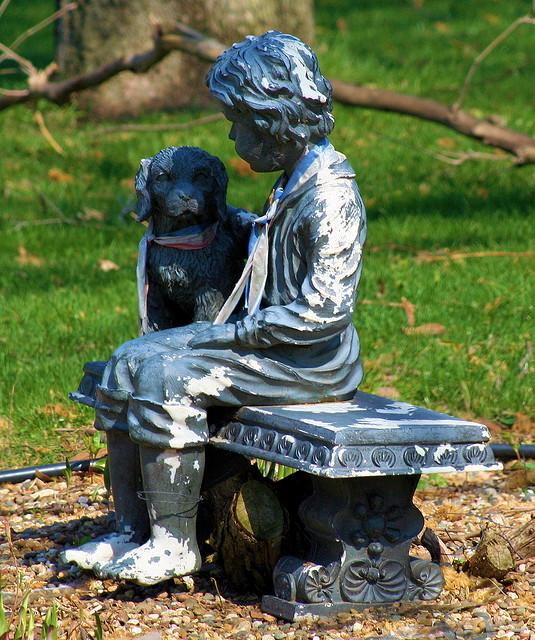Why is this statue partially white?

Choices:
A) age
B) style
C) bird droppings
D) water discoloration bird droppings 